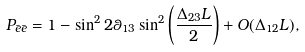<formula> <loc_0><loc_0><loc_500><loc_500>P _ { \bar { e } \bar { e } } = 1 - \sin ^ { 2 } 2 \theta _ { 1 3 } \sin ^ { 2 } \left ( \frac { \Delta _ { 2 3 } L } { 2 } \right ) + O ( \Delta _ { 1 2 } L ) ,</formula> 